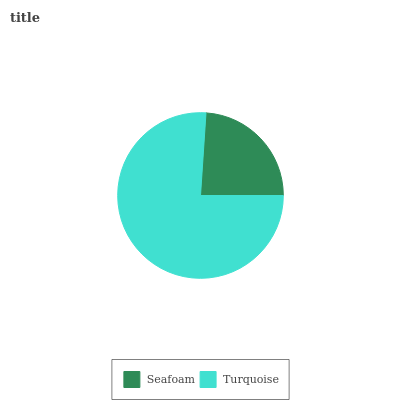Is Seafoam the minimum?
Answer yes or no. Yes. Is Turquoise the maximum?
Answer yes or no. Yes. Is Turquoise the minimum?
Answer yes or no. No. Is Turquoise greater than Seafoam?
Answer yes or no. Yes. Is Seafoam less than Turquoise?
Answer yes or no. Yes. Is Seafoam greater than Turquoise?
Answer yes or no. No. Is Turquoise less than Seafoam?
Answer yes or no. No. Is Turquoise the high median?
Answer yes or no. Yes. Is Seafoam the low median?
Answer yes or no. Yes. Is Seafoam the high median?
Answer yes or no. No. Is Turquoise the low median?
Answer yes or no. No. 